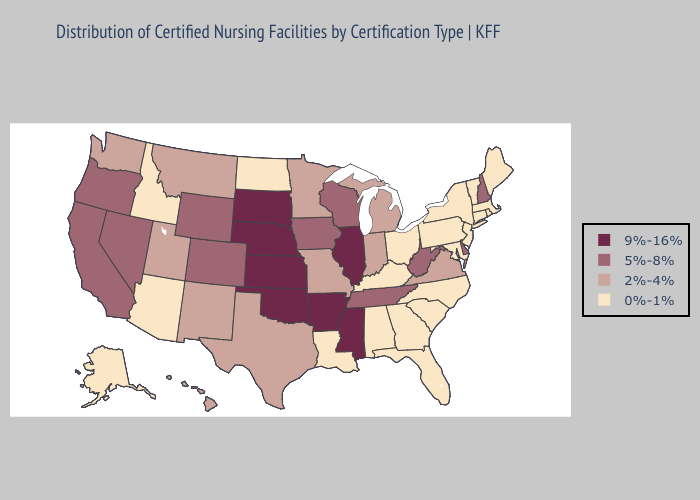Which states have the highest value in the USA?
Give a very brief answer. Arkansas, Illinois, Kansas, Mississippi, Nebraska, Oklahoma, South Dakota. Which states have the lowest value in the USA?
Write a very short answer. Alabama, Alaska, Arizona, Connecticut, Florida, Georgia, Idaho, Kentucky, Louisiana, Maine, Maryland, Massachusetts, New Jersey, New York, North Carolina, North Dakota, Ohio, Pennsylvania, Rhode Island, South Carolina, Vermont. Among the states that border Illinois , does Iowa have the lowest value?
Give a very brief answer. No. Does Montana have the highest value in the USA?
Be succinct. No. Name the states that have a value in the range 9%-16%?
Concise answer only. Arkansas, Illinois, Kansas, Mississippi, Nebraska, Oklahoma, South Dakota. What is the highest value in the USA?
Keep it brief. 9%-16%. What is the value of New Hampshire?
Answer briefly. 5%-8%. What is the highest value in the MidWest ?
Concise answer only. 9%-16%. Name the states that have a value in the range 9%-16%?
Keep it brief. Arkansas, Illinois, Kansas, Mississippi, Nebraska, Oklahoma, South Dakota. What is the value of Ohio?
Write a very short answer. 0%-1%. Name the states that have a value in the range 9%-16%?
Be succinct. Arkansas, Illinois, Kansas, Mississippi, Nebraska, Oklahoma, South Dakota. Is the legend a continuous bar?
Keep it brief. No. What is the value of New Mexico?
Concise answer only. 2%-4%. What is the value of Arizona?
Answer briefly. 0%-1%. Which states have the lowest value in the West?
Keep it brief. Alaska, Arizona, Idaho. 